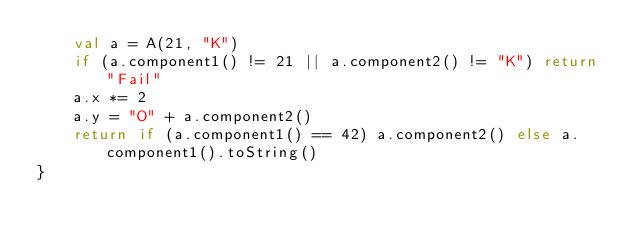Convert code to text. <code><loc_0><loc_0><loc_500><loc_500><_Kotlin_>    val a = A(21, "K")
    if (a.component1() != 21 || a.component2() != "K") return "Fail"
    a.x *= 2
    a.y = "O" + a.component2()
    return if (a.component1() == 42) a.component2() else a.component1().toString()
}
</code> 